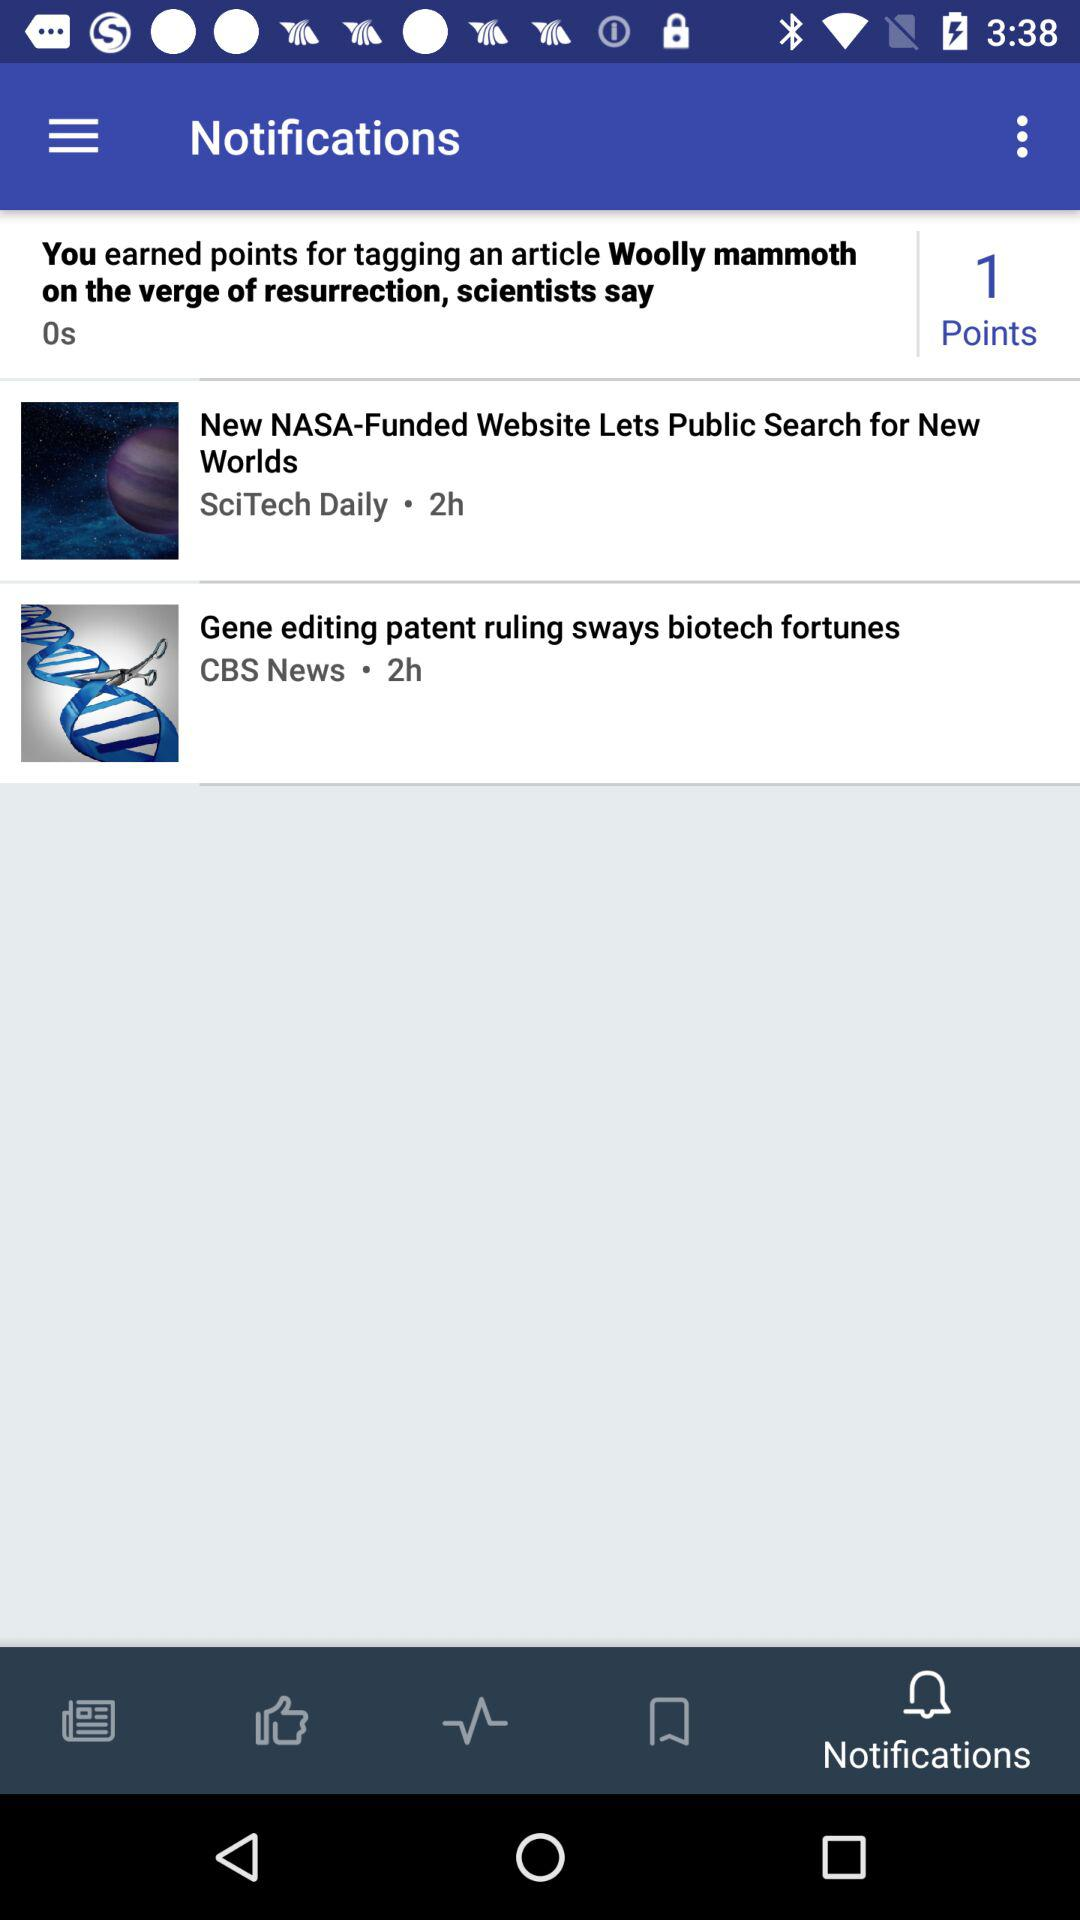How many points have I earned for tagging an article? You have earned 1 point. 